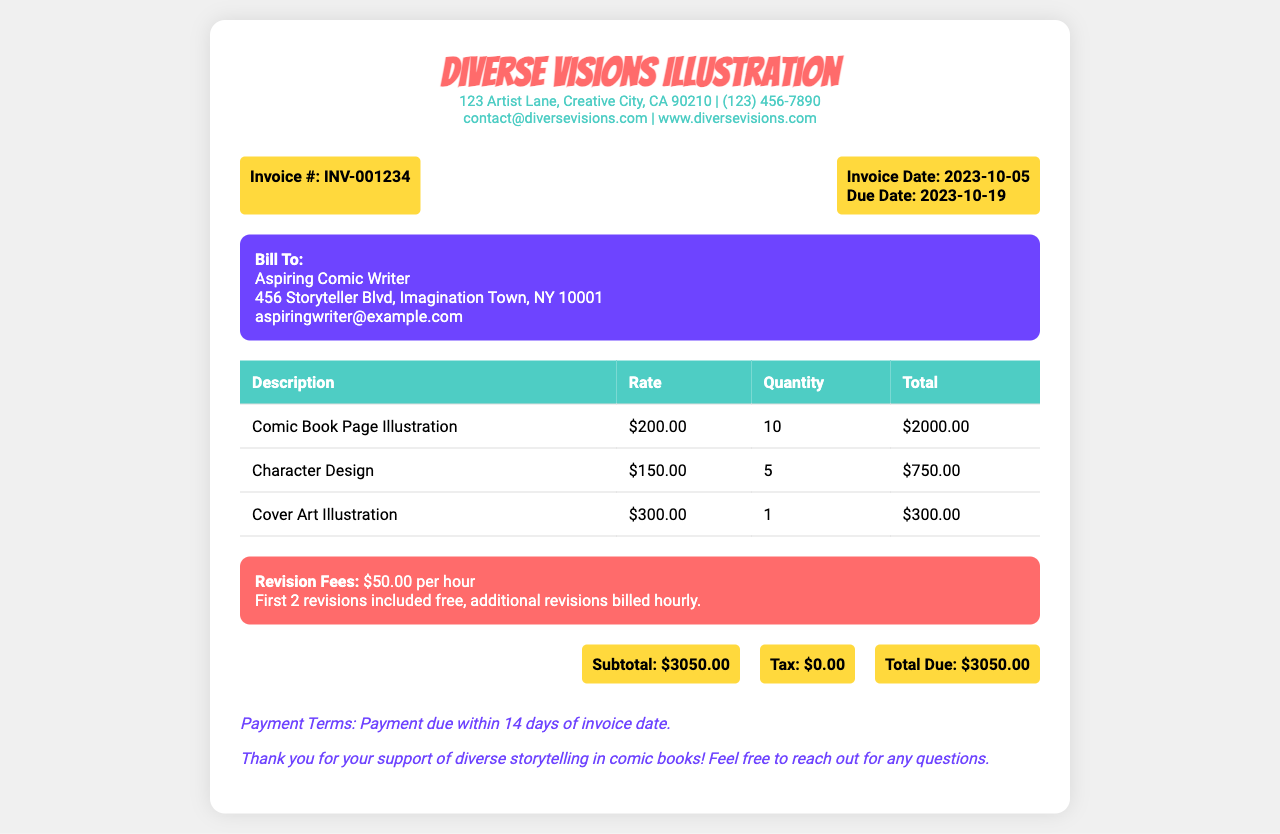What is the invoice number? The invoice number is listed at the top of the document as a reference for the billing.
Answer: INV-001234 What is the total due amount? The total due amount is the final balance that the client must pay for the services rendered.
Answer: $3050.00 What is the rate for comic book page illustration? The rate for this specific service is detailed in the table of services provided in the document.
Answer: $200.00 How many character designs are included? The document states the quantity of services provided, which indicates the number of character designs.
Answer: 5 What is the revision fee per hour? The revision fee is specified in the invoice and indicates any additional costs for revisions beyond the included revisions.
Answer: $50.00 How many revisions are included for free? The document specifies the number of revisions that are included at no additional cost.
Answer: 2 What is the payment term specified in the invoice? The payment term indicates the period within which the payment should be made after receiving the invoice.
Answer: 14 days What is the subtotal before tax? The subtotal is the total of all services rendered before any additional charges or taxes are applied.
Answer: $3050.00 What is the contact email for Diverse Visions Illustration? The email address provided in the contact info section allows clients to reach out with questions or concerns.
Answer: contact@diversevisions.com 